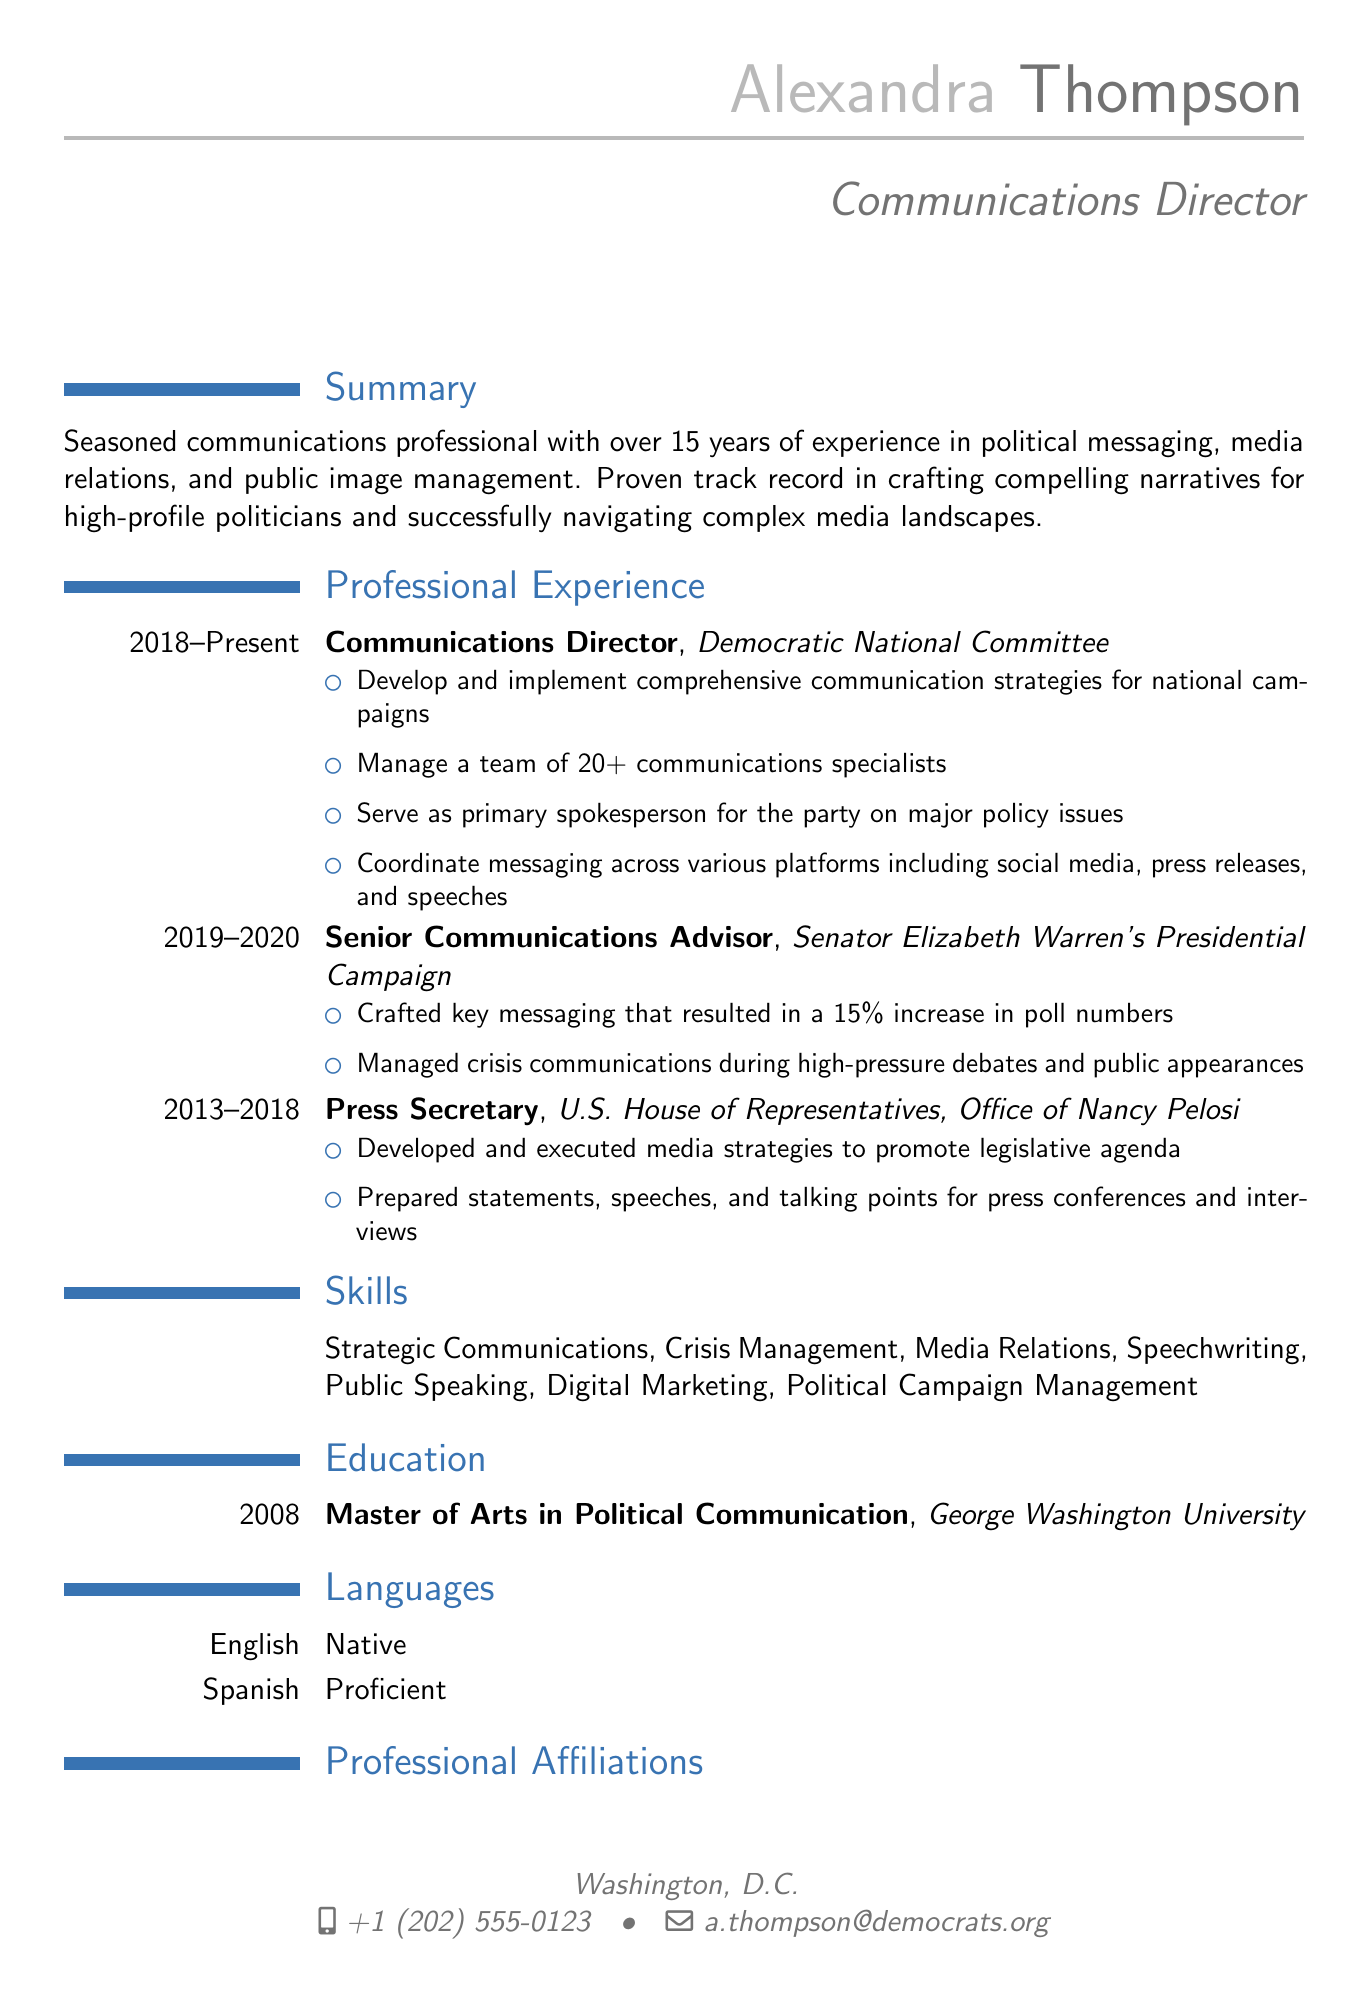What is the name of the person? The name is mentioned in the personal info section of the CV.
Answer: Alexandra Thompson What is the current role of Alexandra Thompson? The current role is identified in the professional experience section.
Answer: Communications Director Which organization is Alexandra currently working for? The organization is stated in the professional experience section for her current role.
Answer: Democratic National Committee In what year did Alexandra obtain her Master's degree? The year is specified in the education section of the CV.
Answer: 2008 What skill is related to managing difficult situations in public communications? This skill can be found in the skills section of the CV.
Answer: Crisis Management How many communications specialists does Alexandra manage? The number is indicated in her current job responsibilities.
Answer: 20+ What percentage increase in poll numbers did Alexandra achieve while working with Senator Warren? This percentage is mentioned in the achievements of her role in the presidential campaign section.
Answer: 15% Which languages does Alexandra speak? The languages are listed in the languages section of the CV.
Answer: English, Spanish What professional organization is Alexandra affiliated with? The affiliations are listed in the professional affiliations section.
Answer: National Association of Political Consultants 